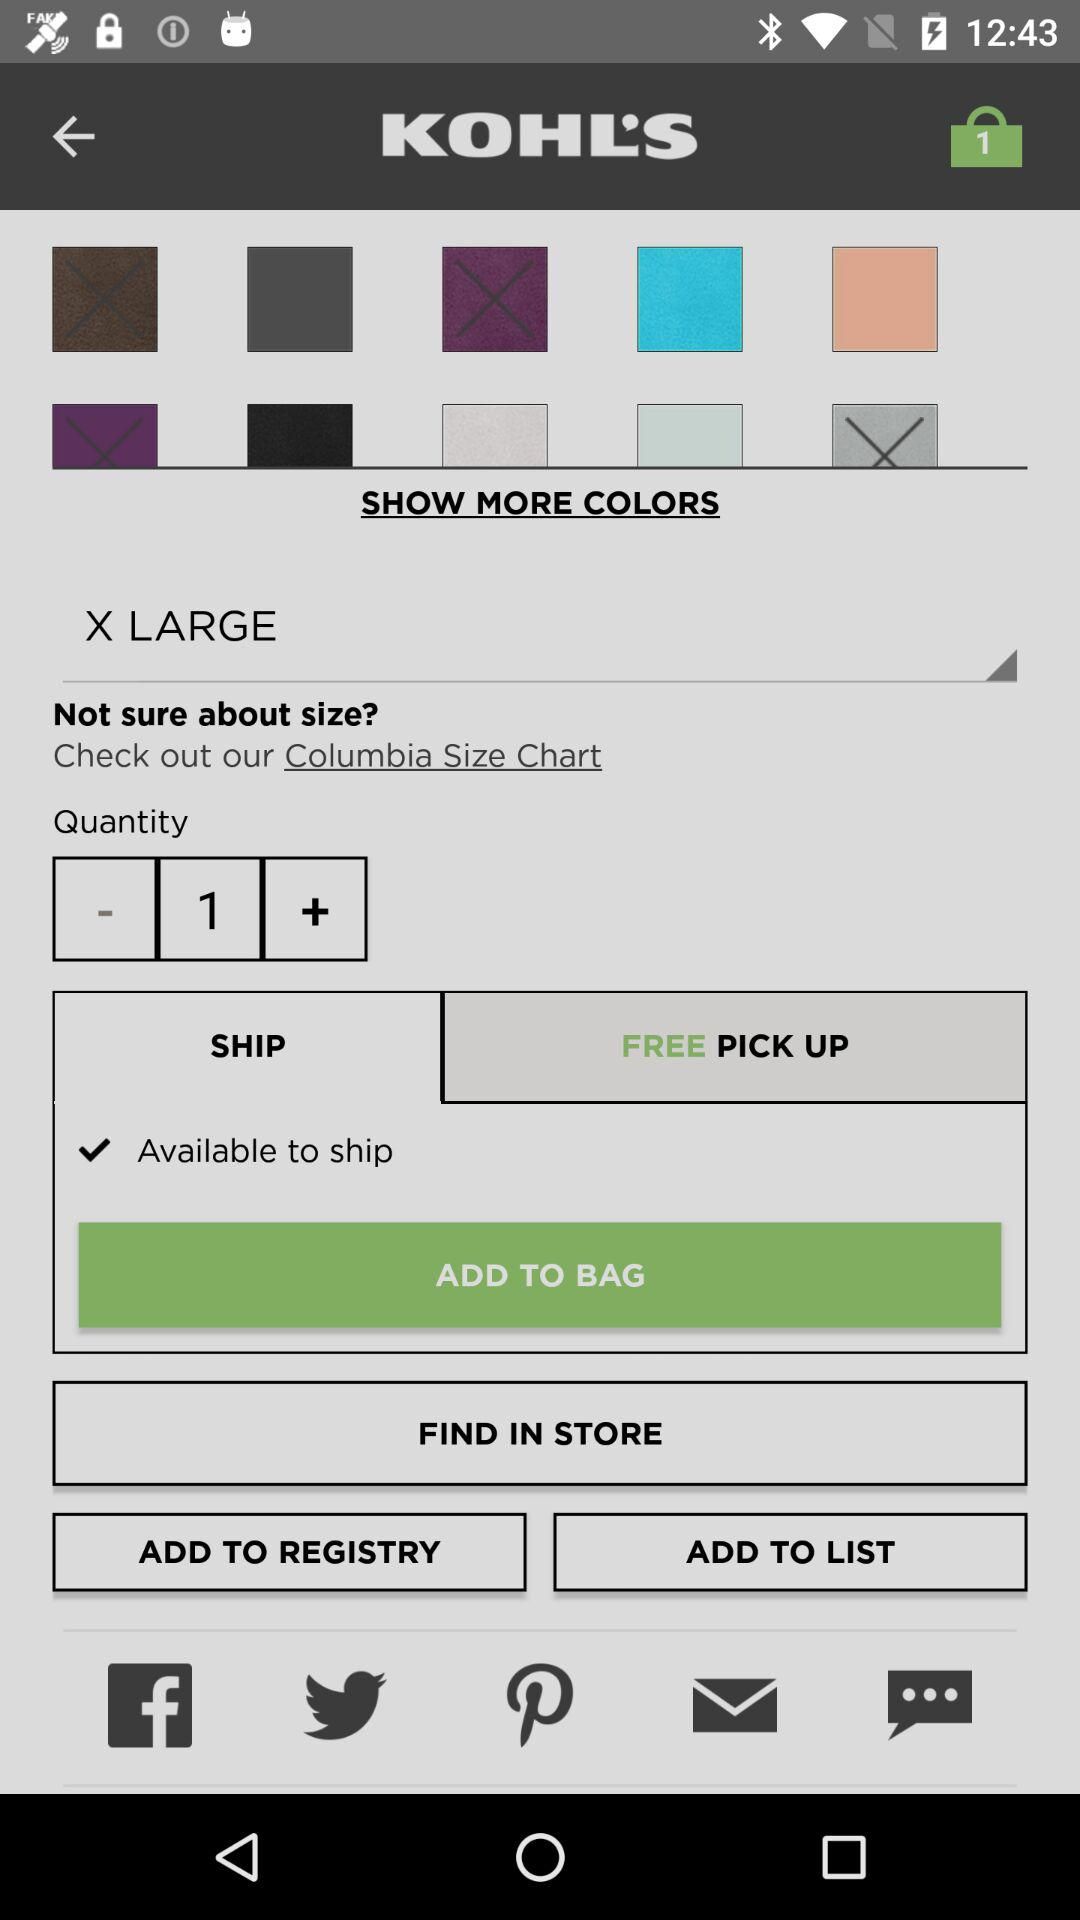How many items are there in the cart? There is 1 item in the cart. 